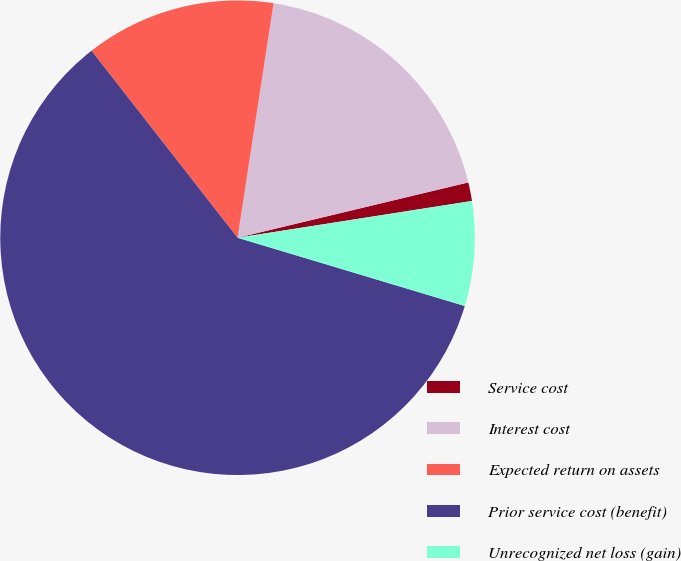Convert chart to OTSL. <chart><loc_0><loc_0><loc_500><loc_500><pie_chart><fcel>Service cost<fcel>Interest cost<fcel>Expected return on assets<fcel>Prior service cost (benefit)<fcel>Unrecognized net loss (gain)<nl><fcel>1.27%<fcel>18.83%<fcel>12.98%<fcel>59.81%<fcel>7.12%<nl></chart> 